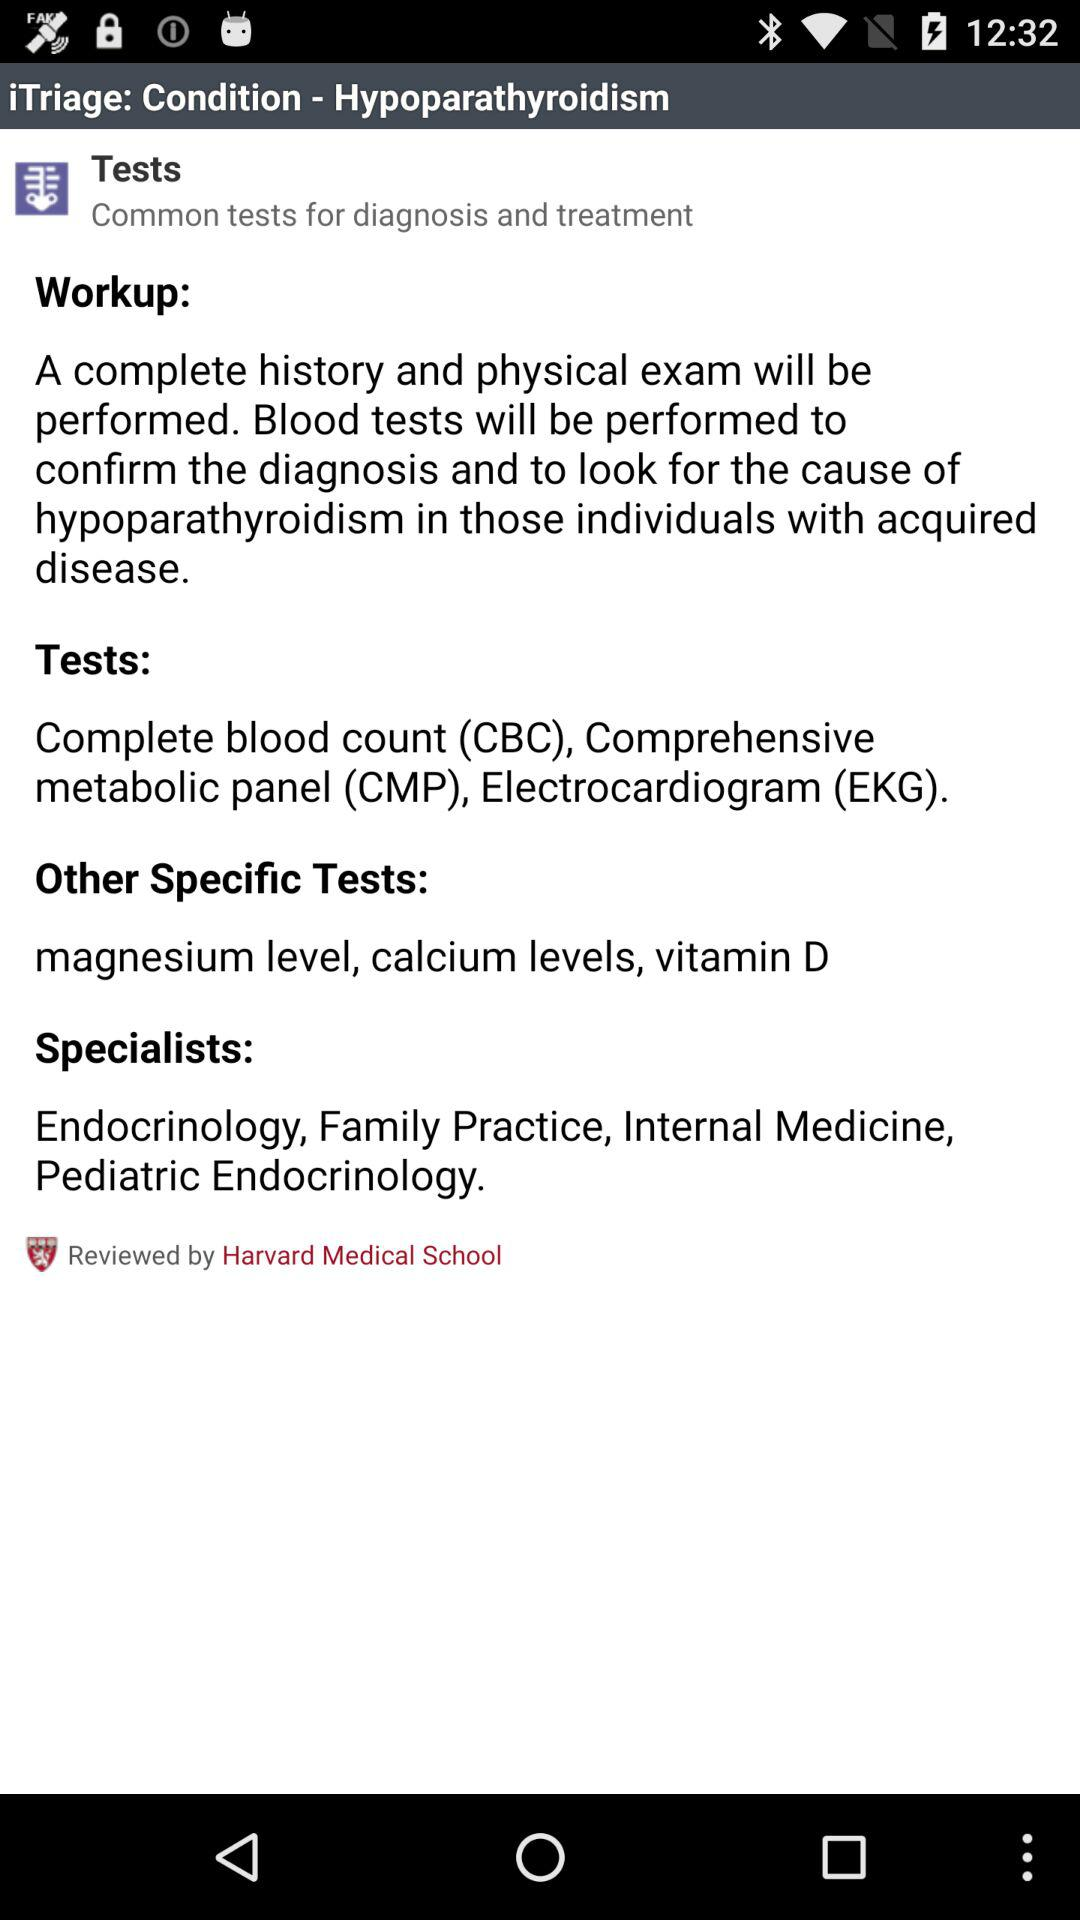What are the other specific tests? The other specific tests are magnesium level, calcium levels and vitamin D. 